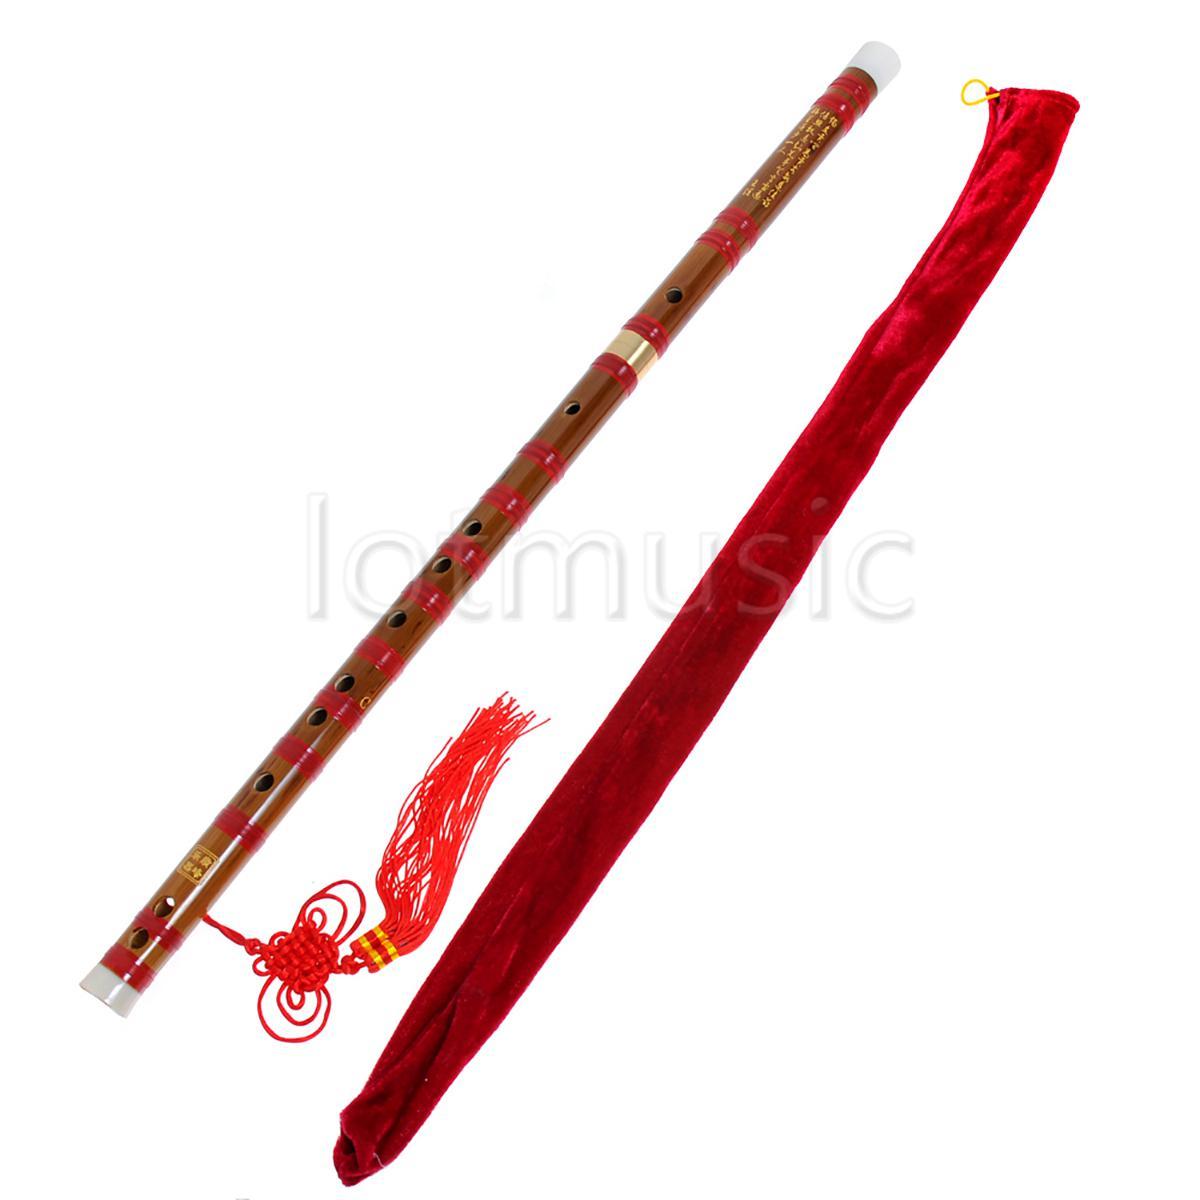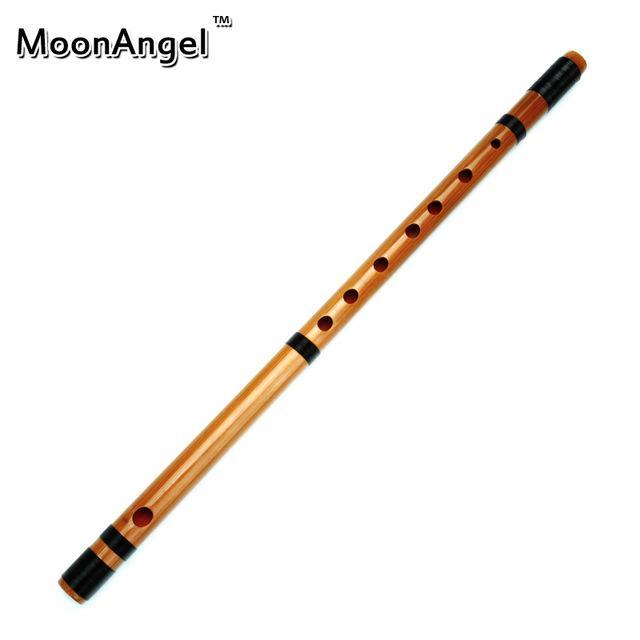The first image is the image on the left, the second image is the image on the right. Examine the images to the left and right. Is the description "One image shows a diagonally displayed, perforated stick-shaped instrument with a red tassel at its lower end, and the other image shows a similar gold and black instrument with no tassel." accurate? Answer yes or no. Yes. The first image is the image on the left, the second image is the image on the right. Assess this claim about the two images: "A red tassel is connected to a straight flute.". Correct or not? Answer yes or no. Yes. 